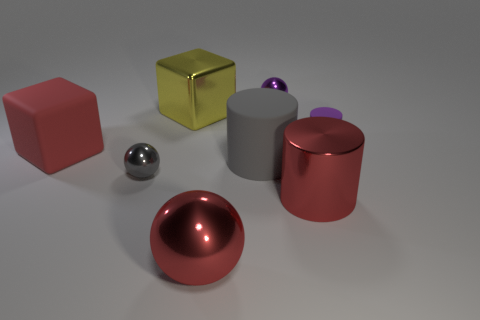Add 2 big metallic things. How many objects exist? 10 Subtract 1 gray cylinders. How many objects are left? 7 Subtract all cubes. How many objects are left? 6 Subtract all yellow metallic things. Subtract all big cubes. How many objects are left? 5 Add 3 small objects. How many small objects are left? 6 Add 2 rubber blocks. How many rubber blocks exist? 3 